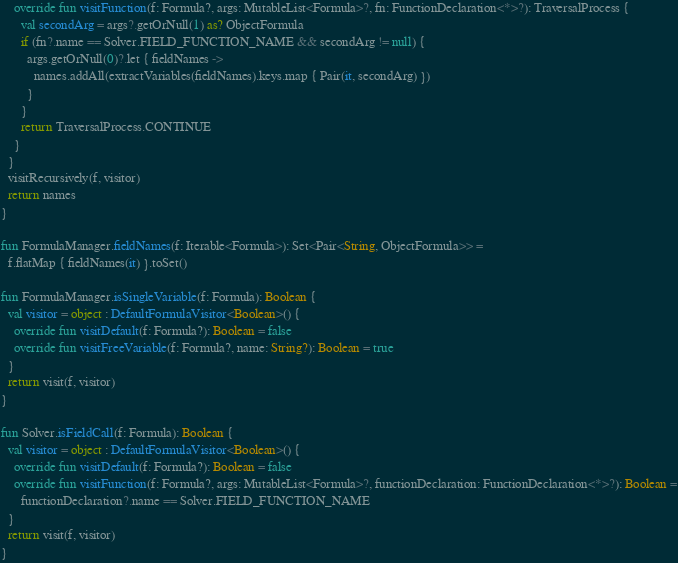Convert code to text. <code><loc_0><loc_0><loc_500><loc_500><_Kotlin_>    override fun visitFunction(f: Formula?, args: MutableList<Formula>?, fn: FunctionDeclaration<*>?): TraversalProcess {
      val secondArg = args?.getOrNull(1) as? ObjectFormula
      if (fn?.name == Solver.FIELD_FUNCTION_NAME && secondArg != null) {
        args.getOrNull(0)?.let { fieldNames ->
          names.addAll(extractVariables(fieldNames).keys.map { Pair(it, secondArg) })
        }
      }
      return TraversalProcess.CONTINUE
    }
  }
  visitRecursively(f, visitor)
  return names
}

fun FormulaManager.fieldNames(f: Iterable<Formula>): Set<Pair<String, ObjectFormula>> =
  f.flatMap { fieldNames(it) }.toSet()

fun FormulaManager.isSingleVariable(f: Formula): Boolean {
  val visitor = object : DefaultFormulaVisitor<Boolean>() {
    override fun visitDefault(f: Formula?): Boolean = false
    override fun visitFreeVariable(f: Formula?, name: String?): Boolean = true
  }
  return visit(f, visitor)
}

fun Solver.isFieldCall(f: Formula): Boolean {
  val visitor = object : DefaultFormulaVisitor<Boolean>() {
    override fun visitDefault(f: Formula?): Boolean = false
    override fun visitFunction(f: Formula?, args: MutableList<Formula>?, functionDeclaration: FunctionDeclaration<*>?): Boolean =
      functionDeclaration?.name == Solver.FIELD_FUNCTION_NAME
  }
  return visit(f, visitor)
}
</code> 